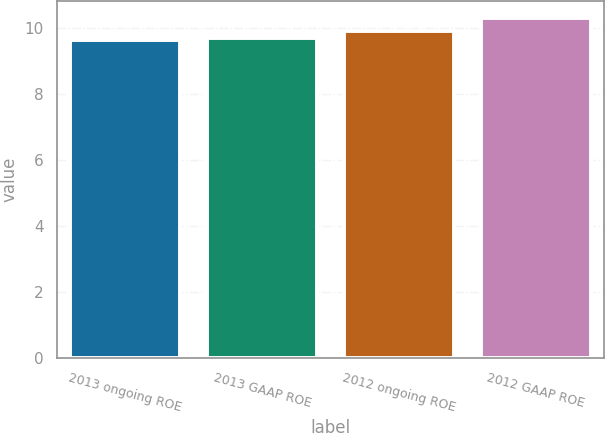Convert chart to OTSL. <chart><loc_0><loc_0><loc_500><loc_500><bar_chart><fcel>2013 ongoing ROE<fcel>2013 GAAP ROE<fcel>2012 ongoing ROE<fcel>2012 GAAP ROE<nl><fcel>9.66<fcel>9.72<fcel>9.92<fcel>10.3<nl></chart> 